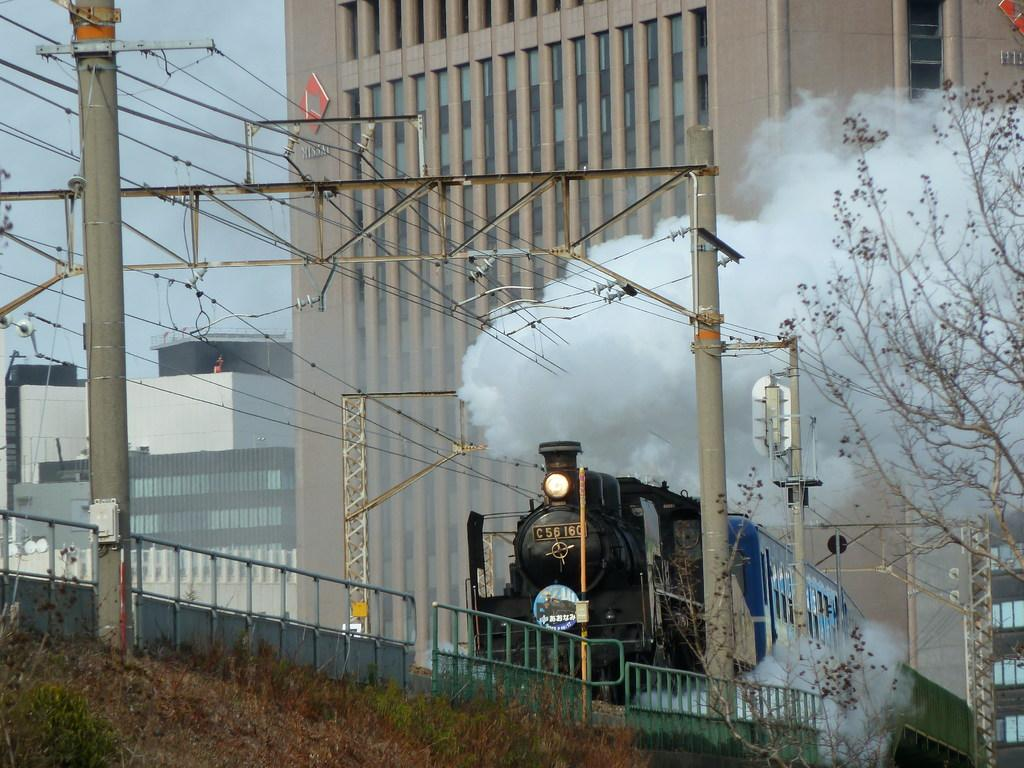What is the main subject of the image? The main subject of the image is a train. What can be seen coming from the train in the image? There is smoke coming from the train in the image. What structures are visible in the image? There are buildings, a fence, and poles visible in the image. What type of vegetation is present in the image? There are trees in the image. What is visible in the background of the image? The sky is visible in the background of the image. What type of wristwatch is visible on the train in the image? There is no wristwatch present on the train in the image. What type of thing is the train embarking on in the image? The image does not depict the train embarking on any journey or thing. 